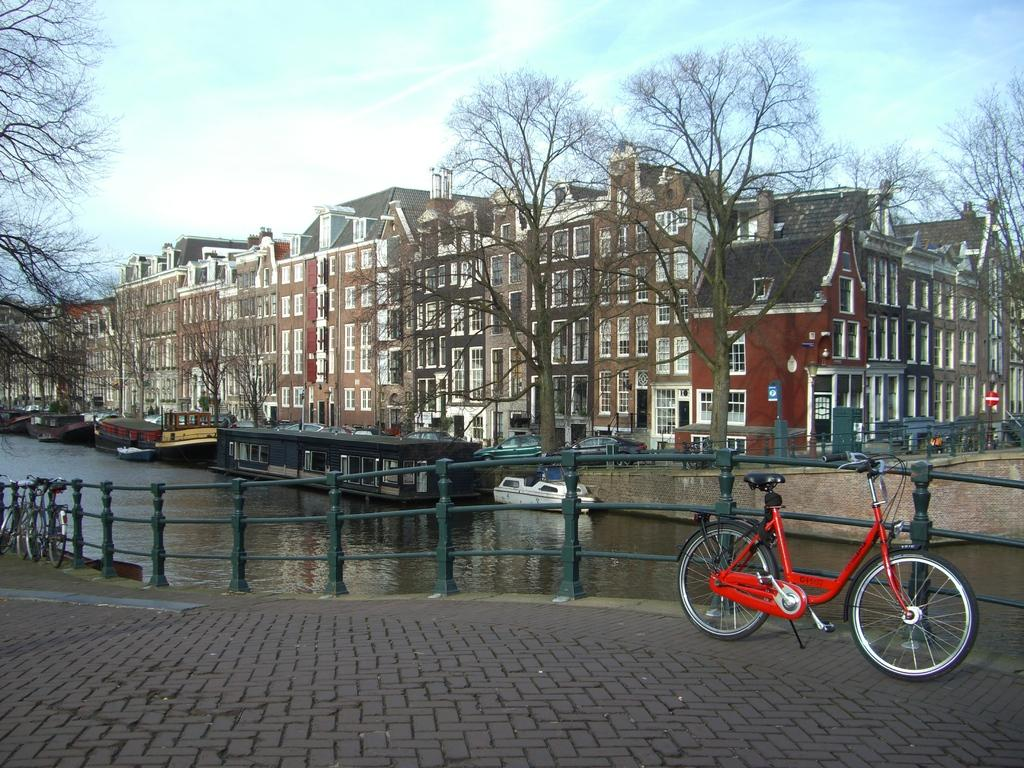What type of vehicles are in the image? There are bicycles in the image. What is separating the bicycles from the water in the image? There is a fence in the image. What is on the water in the image? There are boats on the water in the image. What can be seen in the distance in the image? There are trees and buildings in the background of the image, and the sky is visible in the background as well. What type of voice can be heard coming from the playground in the image? There is no playground present in the image, so it's not possible to determine what type of voice might be heard. 